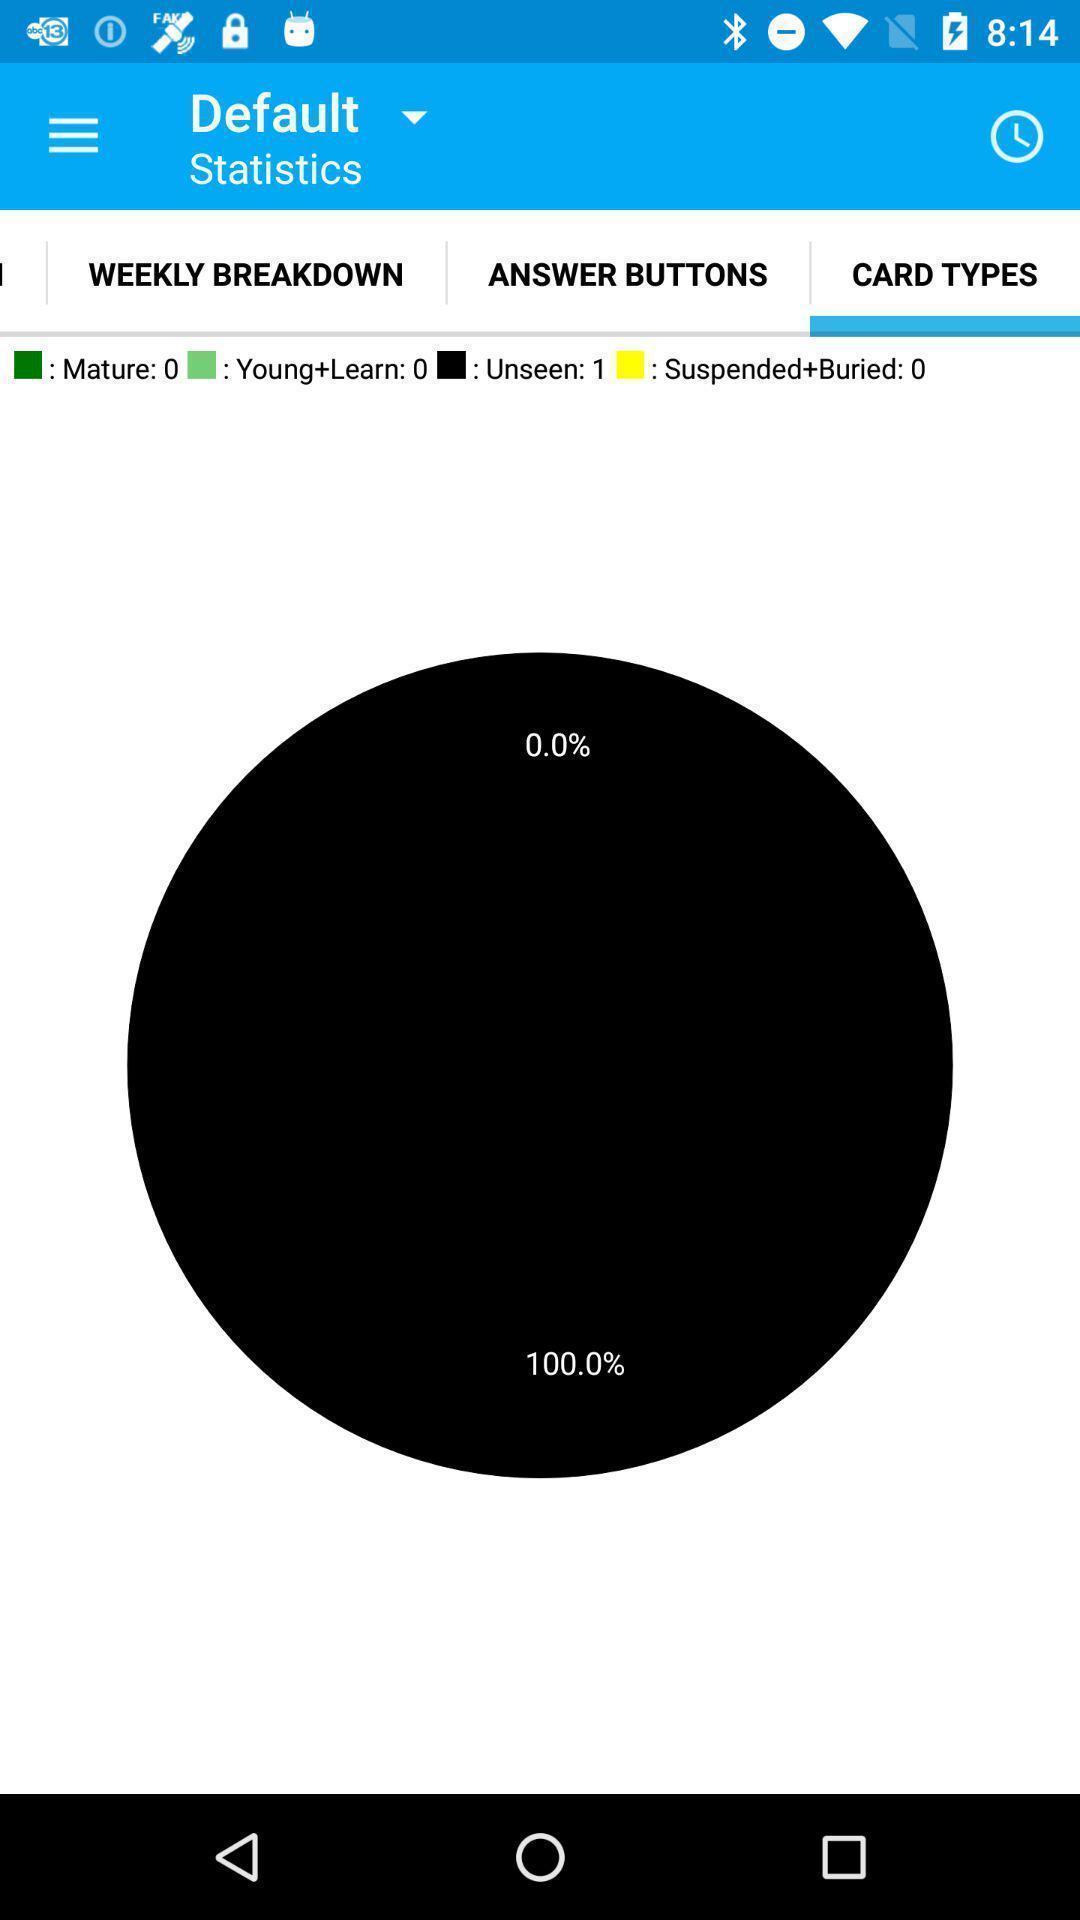Describe the key features of this screenshot. Statistics page. 